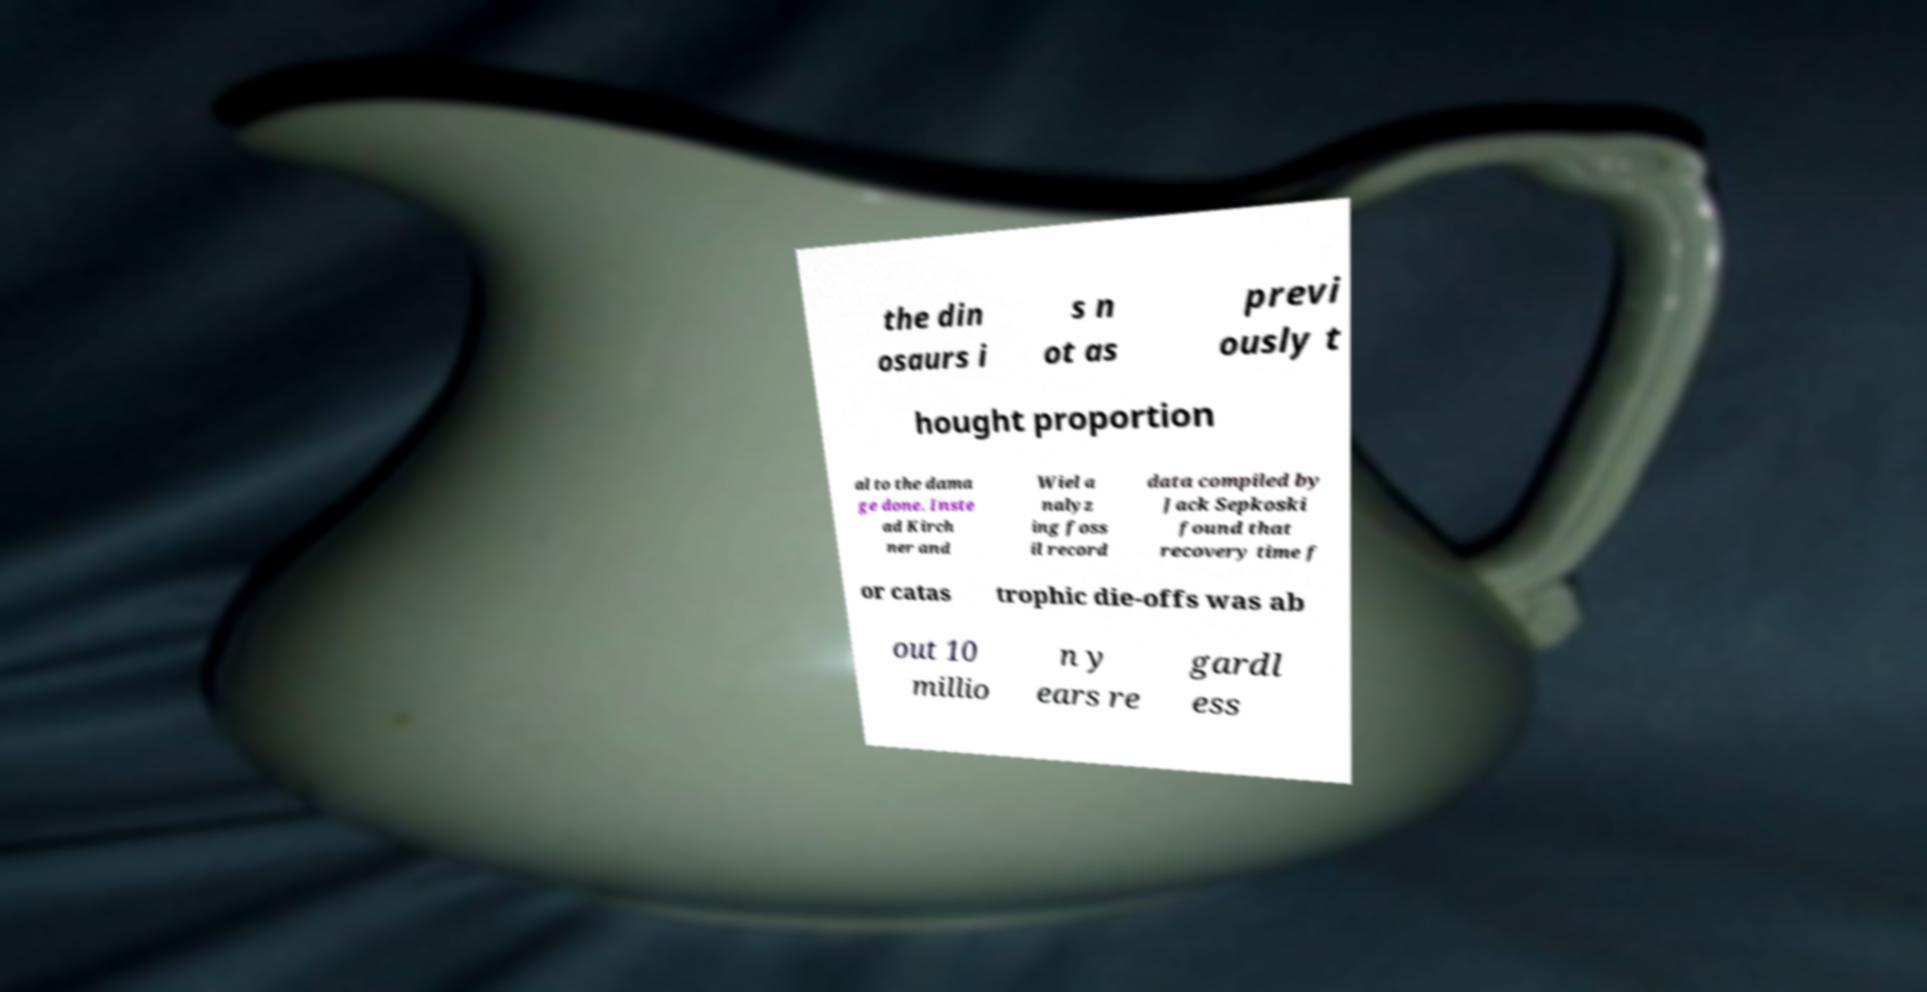I need the written content from this picture converted into text. Can you do that? the din osaurs i s n ot as previ ously t hought proportion al to the dama ge done. Inste ad Kirch ner and Wiel a nalyz ing foss il record data compiled by Jack Sepkoski found that recovery time f or catas trophic die-offs was ab out 10 millio n y ears re gardl ess 